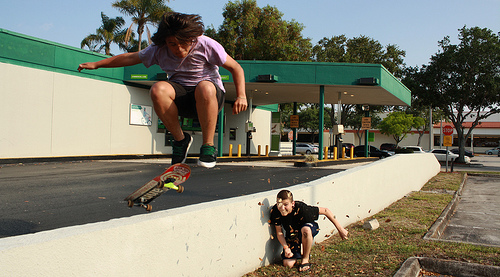What is the activity taking place in the center of the image, and can you describe the emotions observed? The image captures a dynamic skateboarding trick performed by a teenager. Below him, a younger child watches intently, possibly feeling a mix of awe and excitement at the display of skill. 